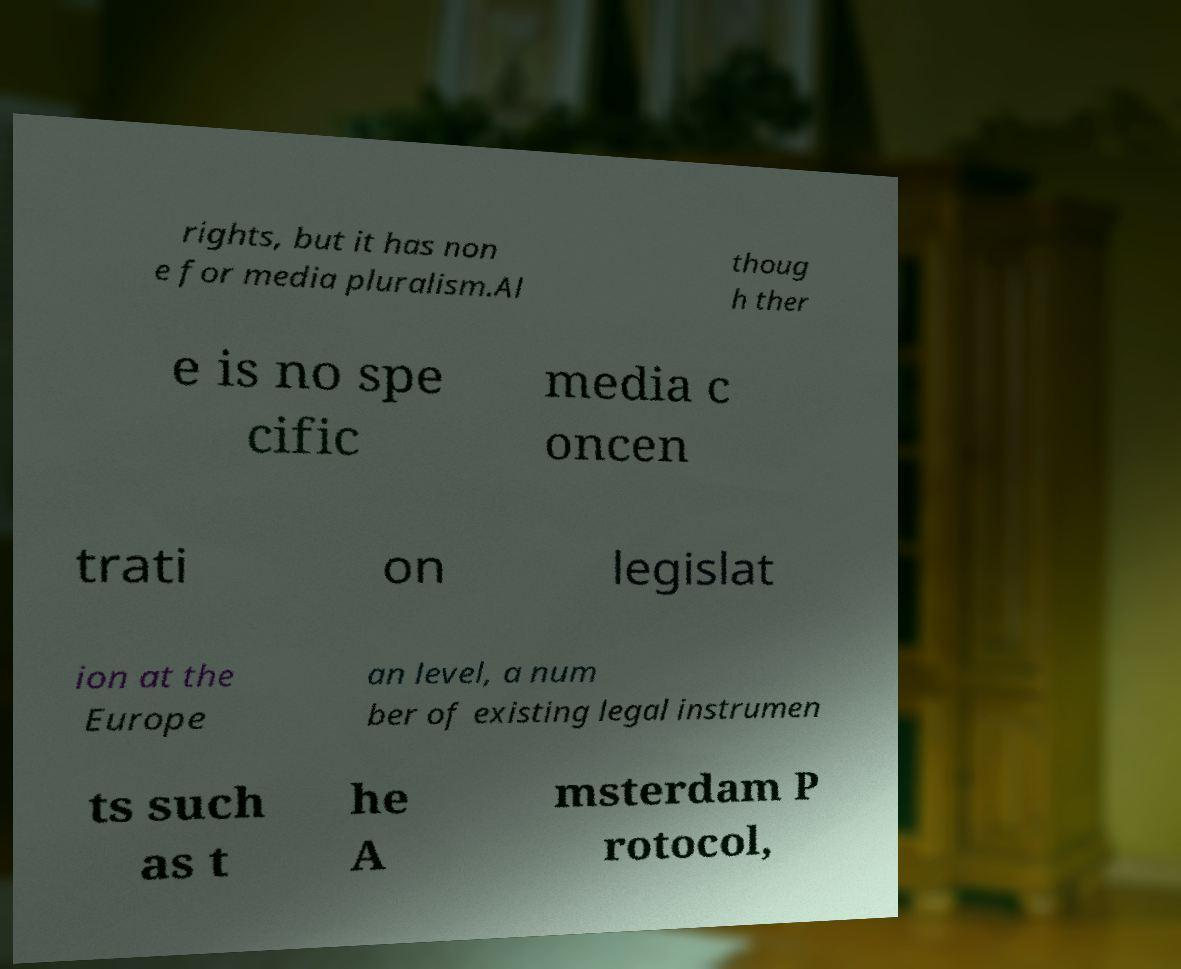For documentation purposes, I need the text within this image transcribed. Could you provide that? rights, but it has non e for media pluralism.Al thoug h ther e is no spe cific media c oncen trati on legislat ion at the Europe an level, a num ber of existing legal instrumen ts such as t he A msterdam P rotocol, 